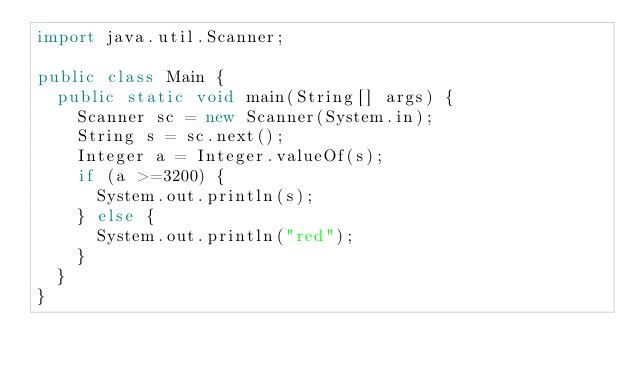<code> <loc_0><loc_0><loc_500><loc_500><_Java_>import java.util.Scanner;

public class Main {
  public static void main(String[] args) {
    Scanner sc = new Scanner(System.in);
    String s = sc.next();
    Integer a = Integer.valueOf(s);
    if (a >=3200) {
      System.out.println(s);
    } else {
      System.out.println("red");
    }
  }
}</code> 